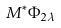Convert formula to latex. <formula><loc_0><loc_0><loc_500><loc_500>M ^ { * } \Phi _ { 2 \lambda }</formula> 